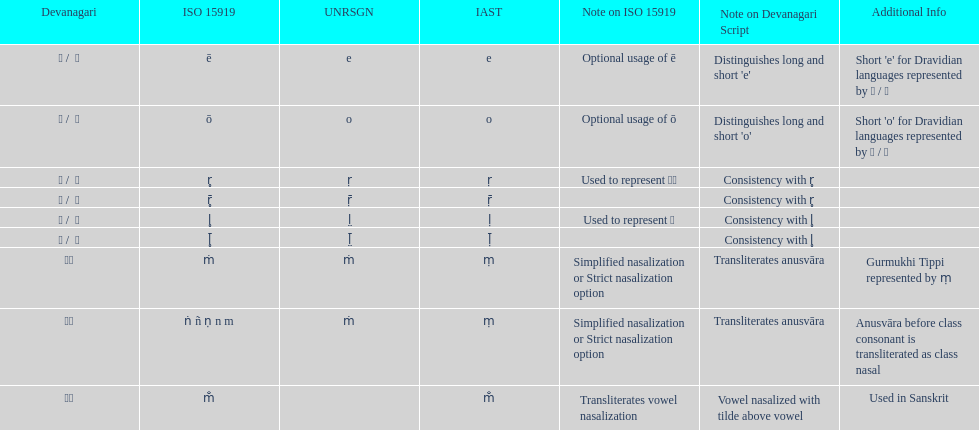This table shows the difference between how many transliterations? 3. 